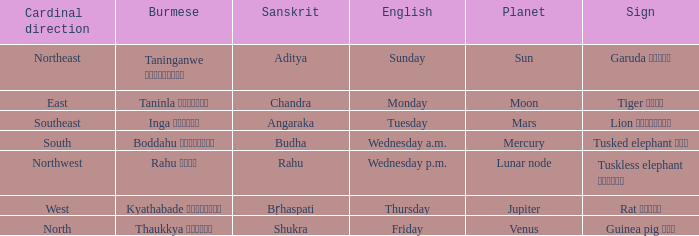What is the burmese word connected to the cardinal direction of west? Kyathabade ကြာသပတေး. 